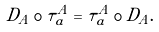Convert formula to latex. <formula><loc_0><loc_0><loc_500><loc_500>D _ { A } \circ \tau ^ { A } _ { a } = \tau ^ { A } _ { a } \circ D _ { A } .</formula> 